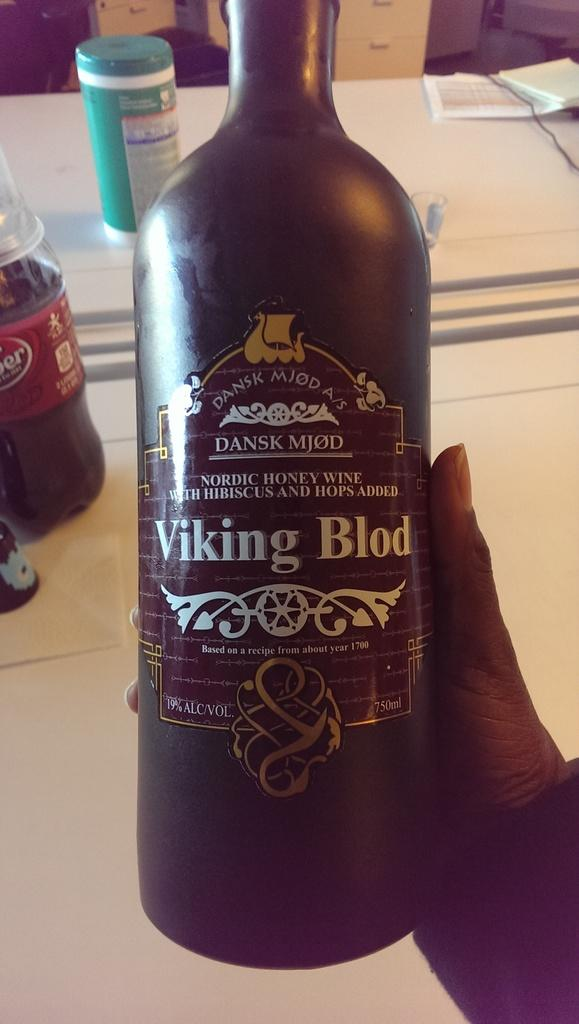<image>
Relay a brief, clear account of the picture shown. a bottle of Viking Blod wine held in someone's hand 